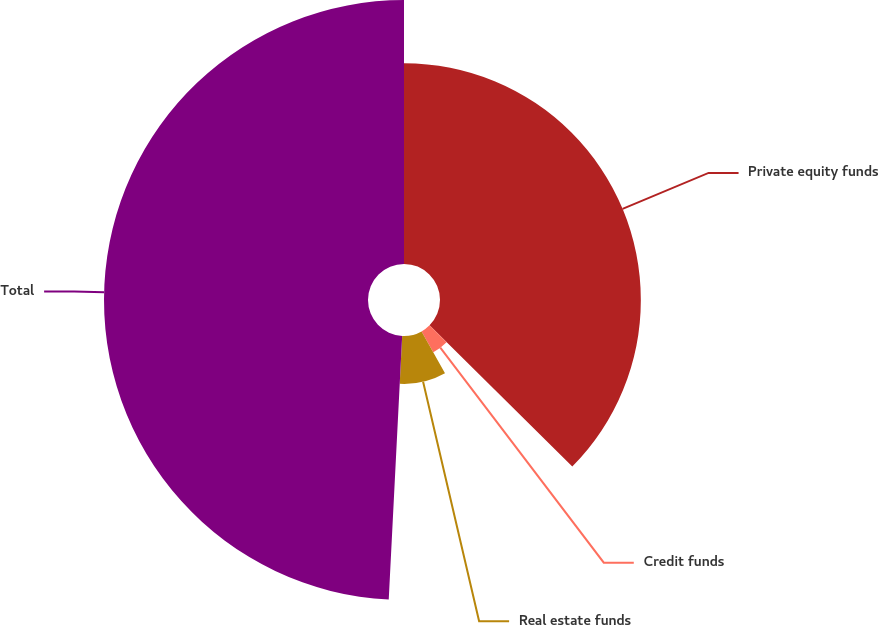Convert chart to OTSL. <chart><loc_0><loc_0><loc_500><loc_500><pie_chart><fcel>Private equity funds<fcel>Credit funds<fcel>Real estate funds<fcel>Total<nl><fcel>37.42%<fcel>4.46%<fcel>8.93%<fcel>49.19%<nl></chart> 